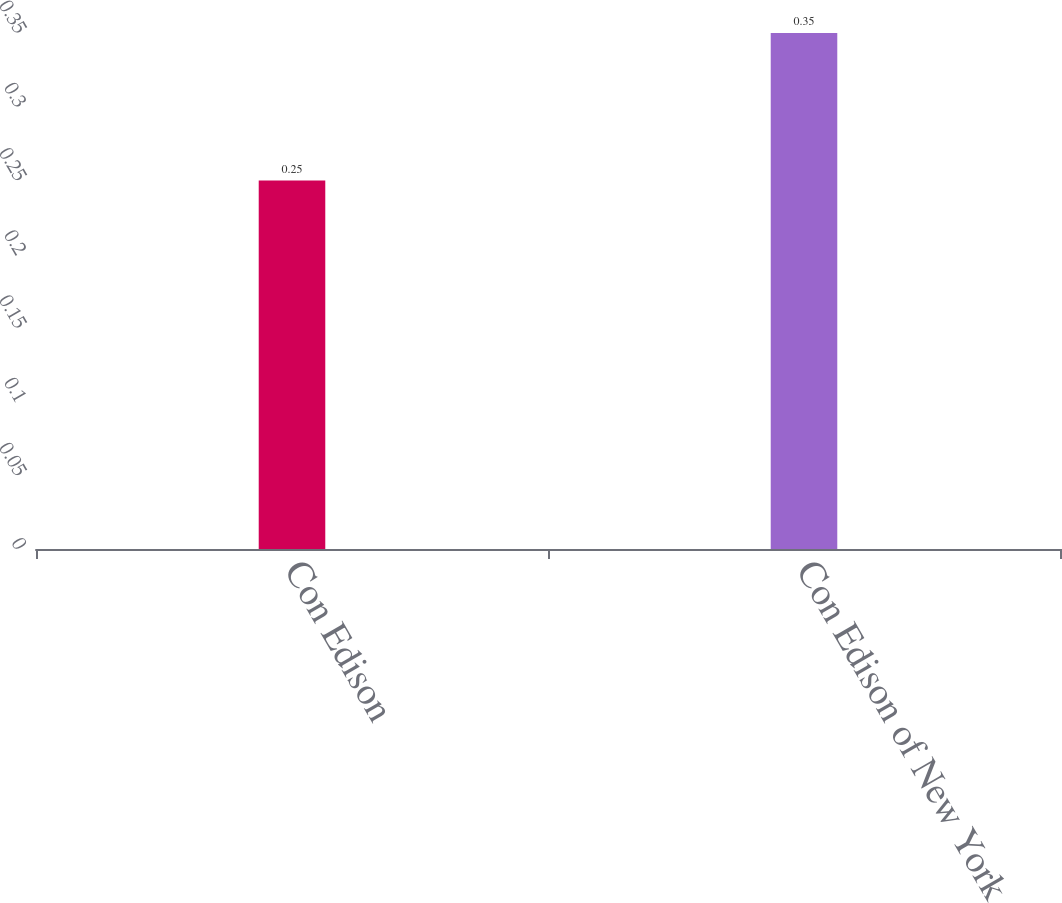Convert chart. <chart><loc_0><loc_0><loc_500><loc_500><bar_chart><fcel>Con Edison<fcel>Con Edison of New York<nl><fcel>0.25<fcel>0.35<nl></chart> 